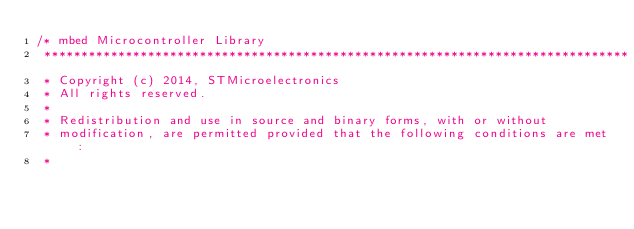<code> <loc_0><loc_0><loc_500><loc_500><_C_>/* mbed Microcontroller Library
 *******************************************************************************
 * Copyright (c) 2014, STMicroelectronics
 * All rights reserved.
 *
 * Redistribution and use in source and binary forms, with or without
 * modification, are permitted provided that the following conditions are met:
 *</code> 